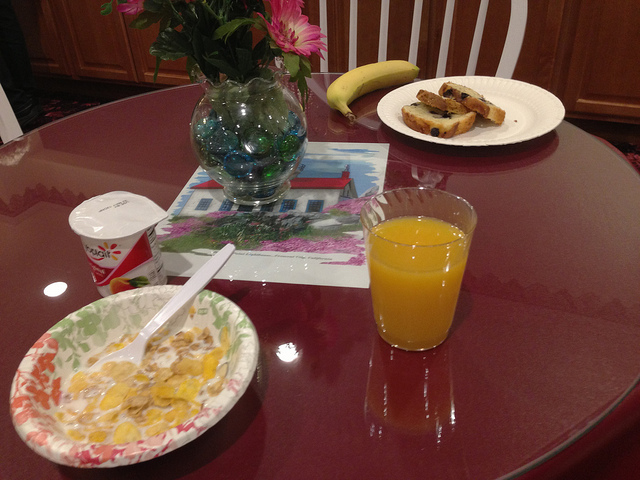What fruit used to prepare items here is darkest?
A. blueberries
B. apricots
C. bananas
D. oranges The darkest fruit used in the items presented in the image is indeed 'A. blueberries'. You can see their rich, dark purple hue prominently featured on the pastries resting on the white plate, which contrasts with the lighter colors of the banana and the orange juice. 